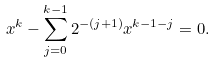<formula> <loc_0><loc_0><loc_500><loc_500>x ^ { k } - \sum _ { j = 0 } ^ { k - 1 } 2 ^ { - ( j + 1 ) } x ^ { k - 1 - j } = 0 .</formula> 